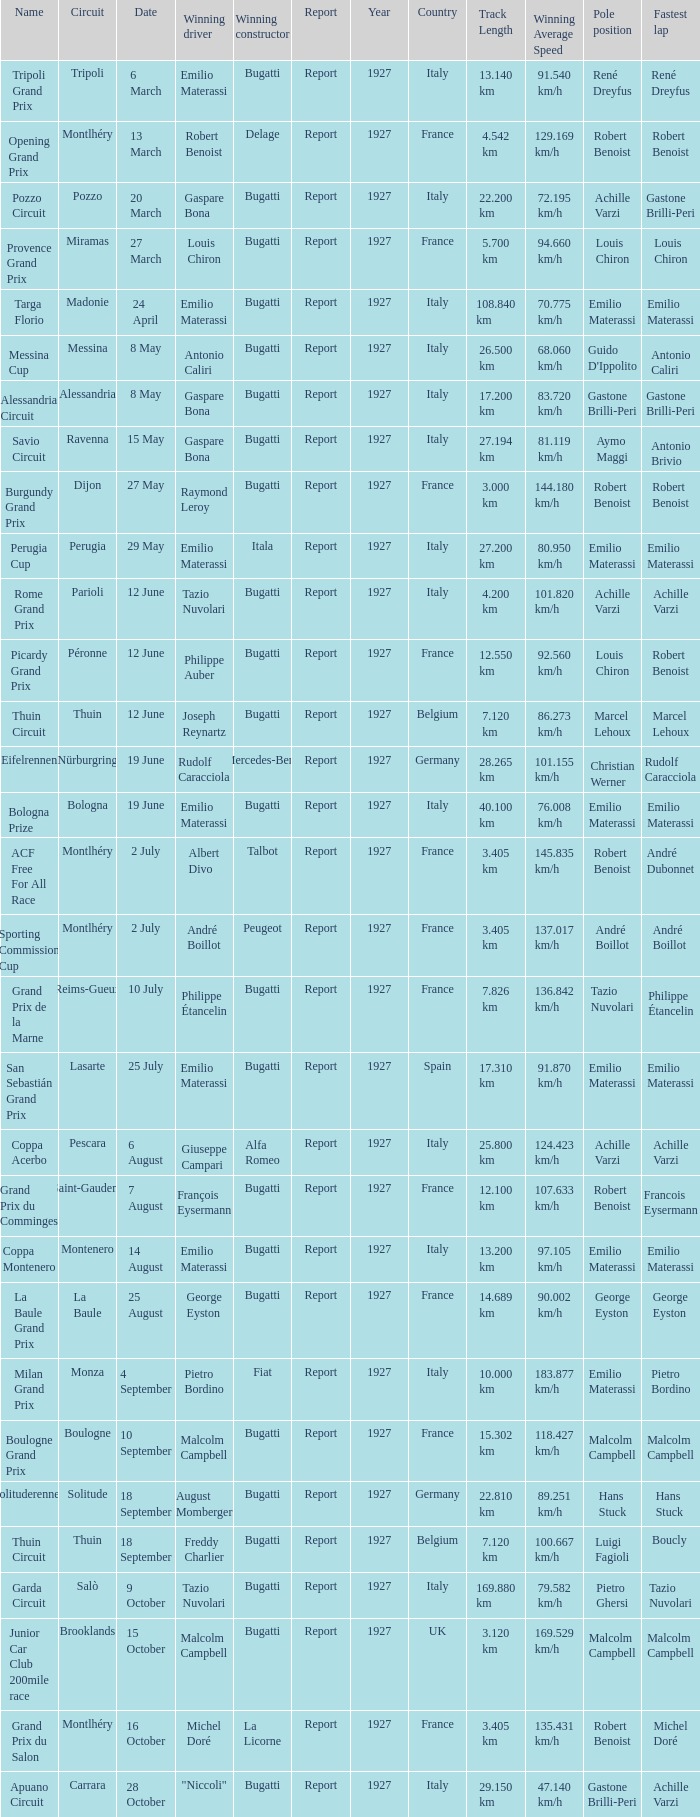Which circuit did françois eysermann win ? Saint-Gaudens. 